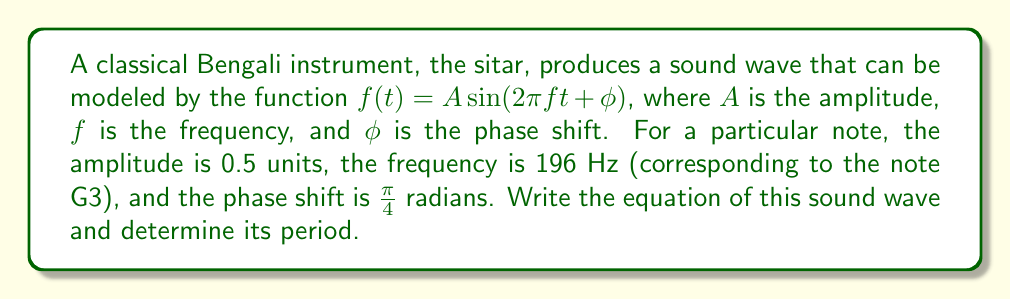Show me your answer to this math problem. To solve this problem, we need to follow these steps:

1) First, let's write the general equation for a sine wave:

   $f(t) = A \sin(2\pi ft + \phi)$

2) We're given the following information:
   - Amplitude (A) = 0.5 units
   - Frequency (f) = 196 Hz
   - Phase shift ($\phi$) = $\frac{\pi}{4}$ radians

3) Let's substitute these values into our general equation:

   $f(t) = 0.5 \sin(2\pi(196)t + \frac{\pi}{4})$

4) To find the period of the wave, we use the formula:

   $T = \frac{1}{f}$

   Where T is the period and f is the frequency.

5) Substituting our frequency:

   $T = \frac{1}{196}$ seconds

6) To simplify this fraction:

   $T = \frac{1}{196} = \frac{5}{980} \approx 0.0051$ seconds

Therefore, the equation of the sound wave is $f(t) = 0.5 \sin(2\pi(196)t + \frac{\pi}{4})$, and its period is $\frac{5}{980}$ seconds or approximately 0.0051 seconds.
Answer: Equation: $f(t) = 0.5 \sin(2\pi(196)t + \frac{\pi}{4})$
Period: $T = \frac{5}{980}$ seconds $\approx 0.0051$ seconds 